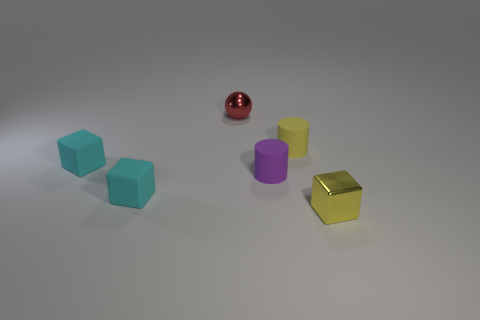Add 4 big green matte spheres. How many objects exist? 10 Subtract all balls. How many objects are left? 5 Subtract 0 blue cubes. How many objects are left? 6 Subtract all small things. Subtract all tiny green shiny things. How many objects are left? 0 Add 1 purple cylinders. How many purple cylinders are left? 2 Add 1 tiny things. How many tiny things exist? 7 